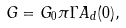<formula> <loc_0><loc_0><loc_500><loc_500>G = G _ { 0 } \pi \Gamma A _ { d } ( 0 ) ,</formula> 